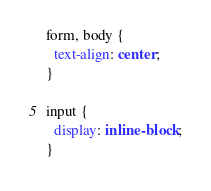Convert code to text. <code><loc_0><loc_0><loc_500><loc_500><_CSS_>form, body {
  text-align: center;
}

input {
  display: inline-block;
}</code> 